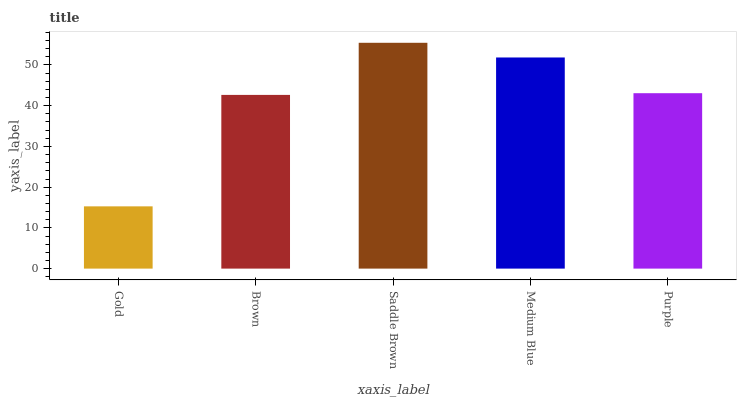Is Gold the minimum?
Answer yes or no. Yes. Is Saddle Brown the maximum?
Answer yes or no. Yes. Is Brown the minimum?
Answer yes or no. No. Is Brown the maximum?
Answer yes or no. No. Is Brown greater than Gold?
Answer yes or no. Yes. Is Gold less than Brown?
Answer yes or no. Yes. Is Gold greater than Brown?
Answer yes or no. No. Is Brown less than Gold?
Answer yes or no. No. Is Purple the high median?
Answer yes or no. Yes. Is Purple the low median?
Answer yes or no. Yes. Is Brown the high median?
Answer yes or no. No. Is Medium Blue the low median?
Answer yes or no. No. 